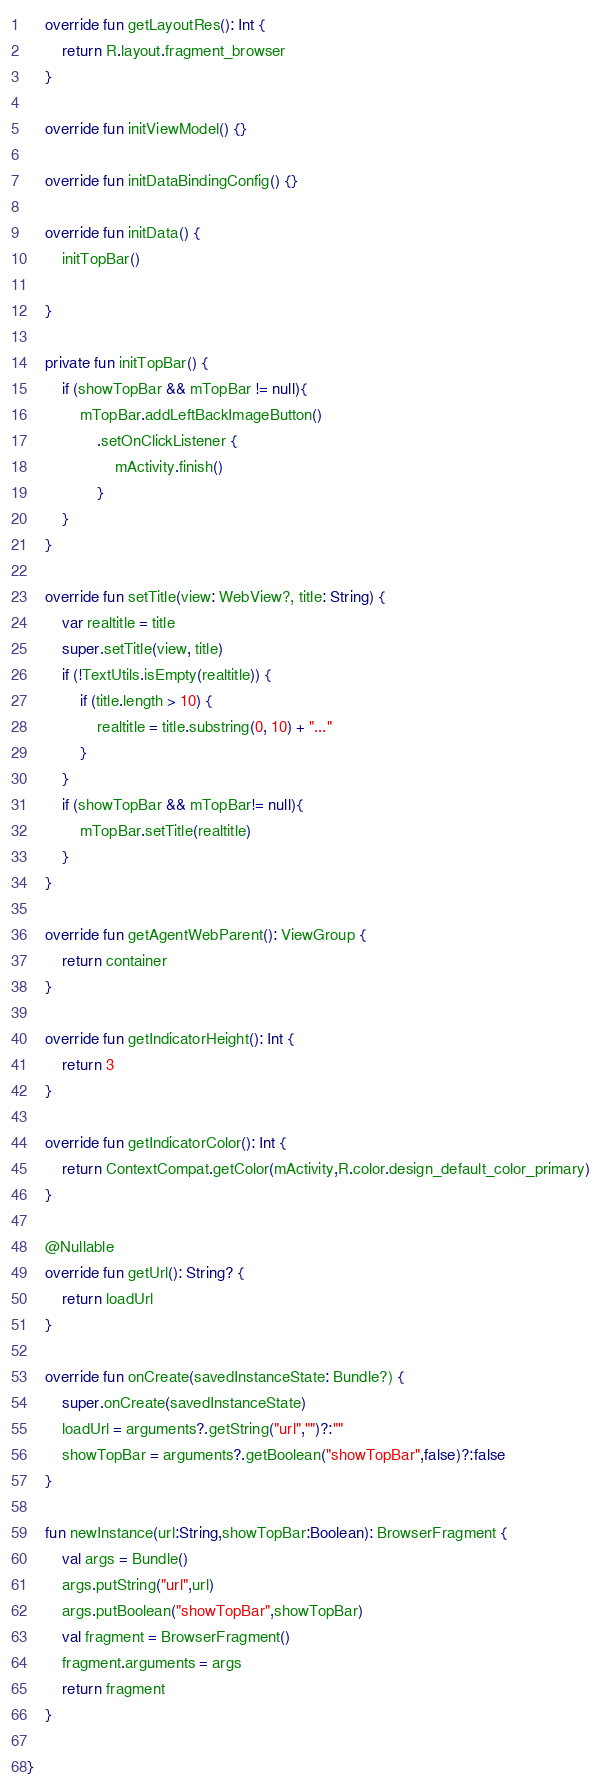<code> <loc_0><loc_0><loc_500><loc_500><_Kotlin_>    override fun getLayoutRes(): Int {
        return R.layout.fragment_browser
    }

    override fun initViewModel() {}

    override fun initDataBindingConfig() {}

    override fun initData() {
        initTopBar()

    }

    private fun initTopBar() {
        if (showTopBar && mTopBar != null){
            mTopBar.addLeftBackImageButton()
                .setOnClickListener {
                    mActivity.finish()
                }
        }
    }

    override fun setTitle(view: WebView?, title: String) {
        var realtitle = title
        super.setTitle(view, title)
        if (!TextUtils.isEmpty(realtitle)) {
            if (title.length > 10) {
                realtitle = title.substring(0, 10) + "..."
            }
        }
        if (showTopBar && mTopBar!= null){
            mTopBar.setTitle(realtitle)
        }
    }

    override fun getAgentWebParent(): ViewGroup {
        return container
    }

    override fun getIndicatorHeight(): Int {
        return 3
    }

    override fun getIndicatorColor(): Int {
        return ContextCompat.getColor(mActivity,R.color.design_default_color_primary)
    }

    @Nullable
    override fun getUrl(): String? {
        return loadUrl
    }

    override fun onCreate(savedInstanceState: Bundle?) {
        super.onCreate(savedInstanceState)
        loadUrl = arguments?.getString("url","")?:""
        showTopBar = arguments?.getBoolean("showTopBar",false)?:false
    }

    fun newInstance(url:String,showTopBar:Boolean): BrowserFragment {
        val args = Bundle()
        args.putString("url",url)
        args.putBoolean("showTopBar",showTopBar)
        val fragment = BrowserFragment()
        fragment.arguments = args
        return fragment
    }

}</code> 